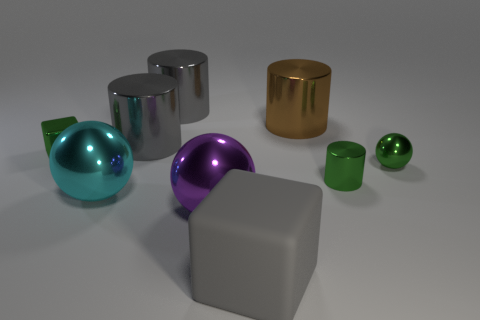What number of gray cylinders have the same material as the green cylinder?
Your response must be concise. 2. Are there any other rubber objects that have the same shape as the large matte thing?
Offer a terse response. No. The rubber object that is the same size as the brown metallic object is what shape?
Provide a succinct answer. Cube. There is a rubber thing; does it have the same color as the small metallic thing that is behind the tiny metallic sphere?
Offer a very short reply. No. How many large cyan metal balls are left of the cube that is in front of the green cylinder?
Offer a terse response. 1. There is a green object that is both right of the metallic block and to the left of the green metal sphere; how big is it?
Your answer should be very brief. Small. Are there any matte things of the same size as the brown metal object?
Your answer should be compact. Yes. Is the number of large metal things that are left of the big brown metal object greater than the number of green metal objects that are behind the green shiny sphere?
Give a very brief answer. Yes. Do the purple object and the gray object in front of the cyan shiny thing have the same material?
Offer a terse response. No. What number of big gray matte objects are behind the cube behind the metal ball that is right of the big rubber block?
Your answer should be compact. 0. 